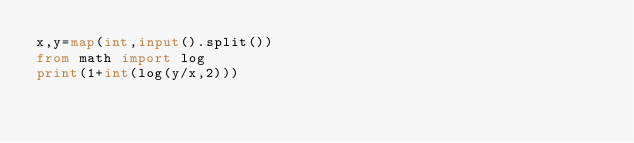Convert code to text. <code><loc_0><loc_0><loc_500><loc_500><_Python_>x,y=map(int,input().split())
from math import log
print(1+int(log(y/x,2)))
</code> 